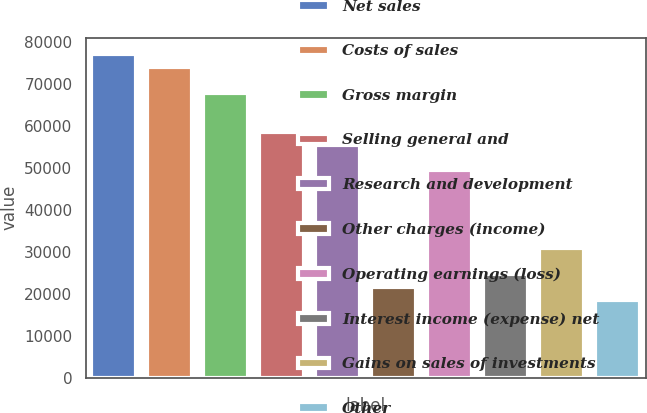<chart> <loc_0><loc_0><loc_500><loc_500><bar_chart><fcel>Net sales<fcel>Costs of sales<fcel>Gross margin<fcel>Selling general and<fcel>Research and development<fcel>Other charges (income)<fcel>Operating earnings (loss)<fcel>Interest income (expense) net<fcel>Gains on sales of investments<fcel>Other<nl><fcel>77304.7<fcel>74212.5<fcel>68028.1<fcel>58751.6<fcel>55659.4<fcel>21645.4<fcel>49475<fcel>24737.6<fcel>30922<fcel>18553.2<nl></chart> 